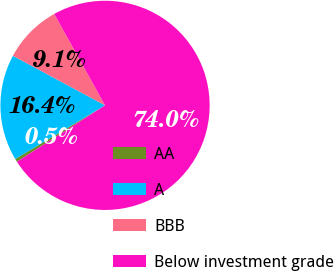Convert chart. <chart><loc_0><loc_0><loc_500><loc_500><pie_chart><fcel>AA<fcel>A<fcel>BBB<fcel>Below investment grade<nl><fcel>0.48%<fcel>16.43%<fcel>9.07%<fcel>74.02%<nl></chart> 